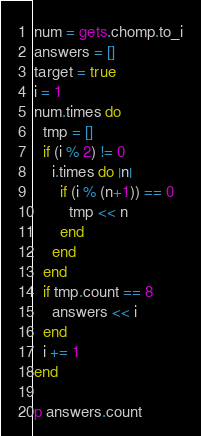<code> <loc_0><loc_0><loc_500><loc_500><_Ruby_>num = gets.chomp.to_i
answers = []
target = true
i = 1
num.times do
  tmp = []
  if (i % 2) != 0
    i.times do |n|
      if (i % (n+1)) == 0
        tmp << n
      end
    end
  end
  if tmp.count == 8
    answers << i
  end
  i += 1
end

p answers.count</code> 